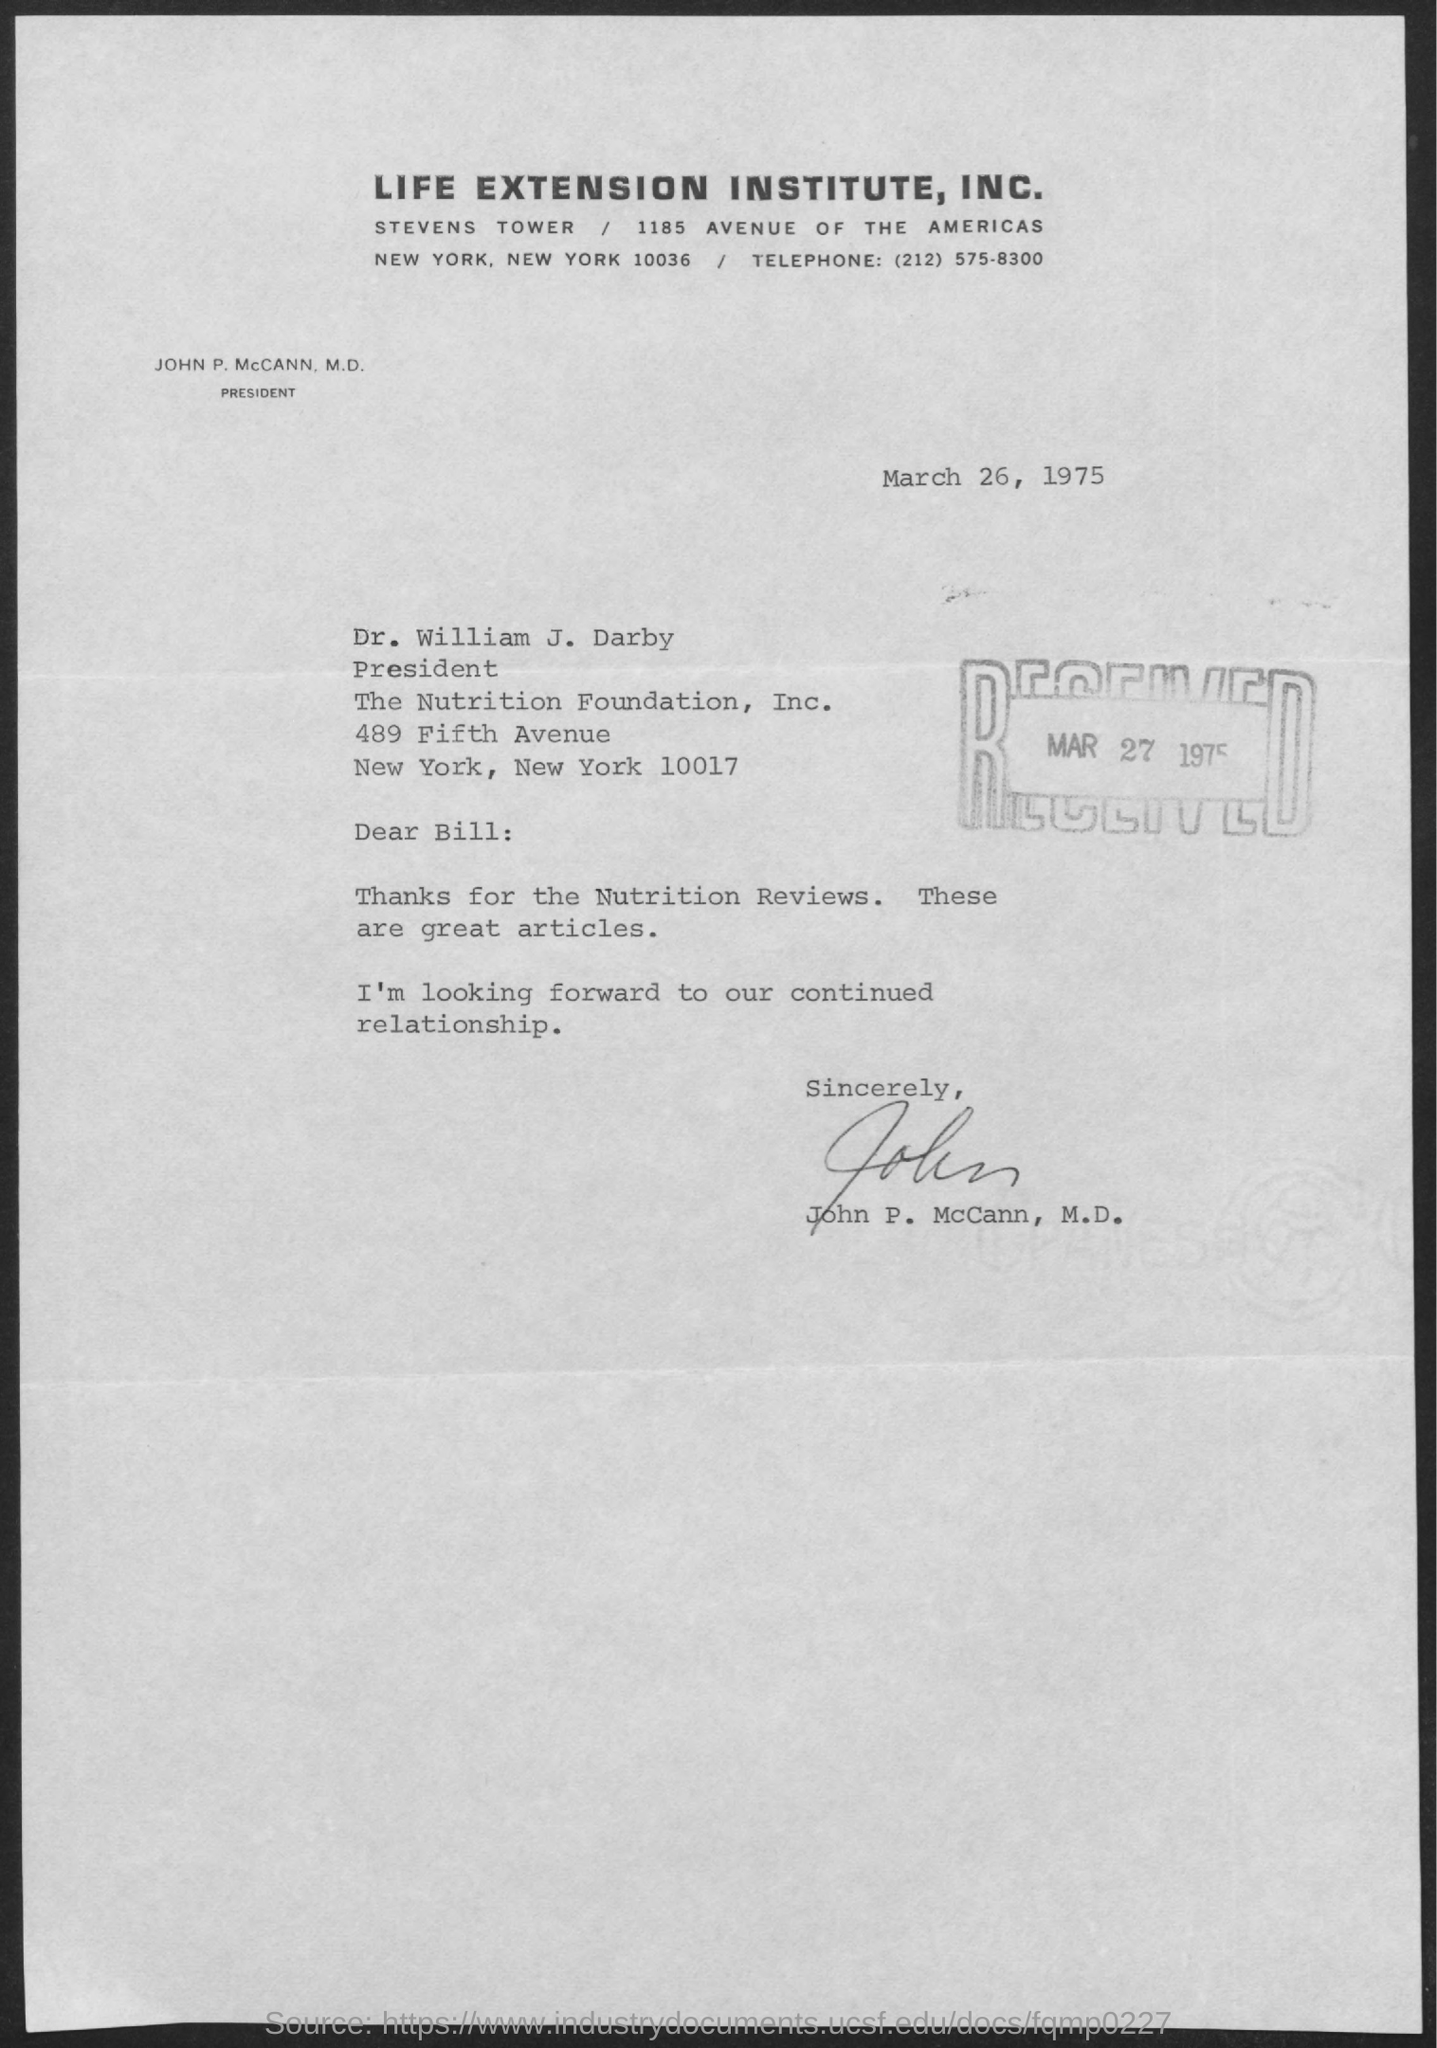Who is the President of Life extension institute?
Your answer should be compact. JOHN P. McCANN, M.D. When is the document dated?
Give a very brief answer. March 26, 1975. When was the letter received?
Give a very brief answer. MAR 27 1975. To whom is the letter addressed?
Give a very brief answer. Bill. 